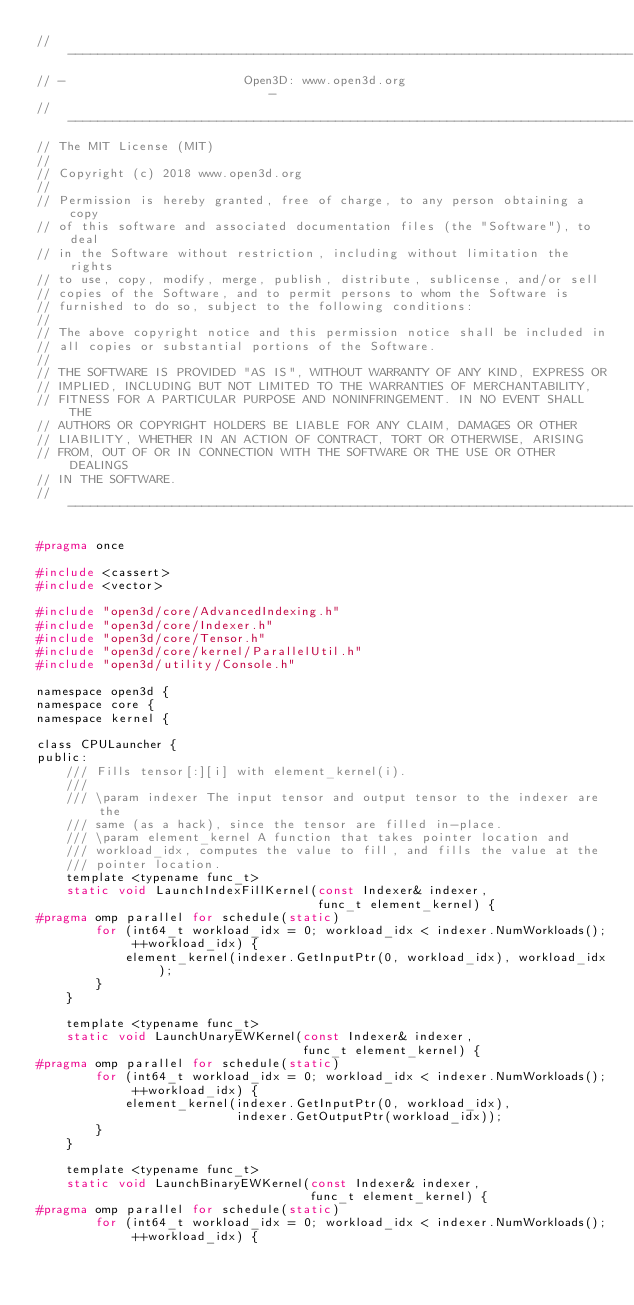<code> <loc_0><loc_0><loc_500><loc_500><_C_>// ----------------------------------------------------------------------------
// -                        Open3D: www.open3d.org                            -
// ----------------------------------------------------------------------------
// The MIT License (MIT)
//
// Copyright (c) 2018 www.open3d.org
//
// Permission is hereby granted, free of charge, to any person obtaining a copy
// of this software and associated documentation files (the "Software"), to deal
// in the Software without restriction, including without limitation the rights
// to use, copy, modify, merge, publish, distribute, sublicense, and/or sell
// copies of the Software, and to permit persons to whom the Software is
// furnished to do so, subject to the following conditions:
//
// The above copyright notice and this permission notice shall be included in
// all copies or substantial portions of the Software.
//
// THE SOFTWARE IS PROVIDED "AS IS", WITHOUT WARRANTY OF ANY KIND, EXPRESS OR
// IMPLIED, INCLUDING BUT NOT LIMITED TO THE WARRANTIES OF MERCHANTABILITY,
// FITNESS FOR A PARTICULAR PURPOSE AND NONINFRINGEMENT. IN NO EVENT SHALL THE
// AUTHORS OR COPYRIGHT HOLDERS BE LIABLE FOR ANY CLAIM, DAMAGES OR OTHER
// LIABILITY, WHETHER IN AN ACTION OF CONTRACT, TORT OR OTHERWISE, ARISING
// FROM, OUT OF OR IN CONNECTION WITH THE SOFTWARE OR THE USE OR OTHER DEALINGS
// IN THE SOFTWARE.
// ----------------------------------------------------------------------------

#pragma once

#include <cassert>
#include <vector>

#include "open3d/core/AdvancedIndexing.h"
#include "open3d/core/Indexer.h"
#include "open3d/core/Tensor.h"
#include "open3d/core/kernel/ParallelUtil.h"
#include "open3d/utility/Console.h"

namespace open3d {
namespace core {
namespace kernel {

class CPULauncher {
public:
    /// Fills tensor[:][i] with element_kernel(i).
    ///
    /// \param indexer The input tensor and output tensor to the indexer are the
    /// same (as a hack), since the tensor are filled in-place.
    /// \param element_kernel A function that takes pointer location and
    /// workload_idx, computes the value to fill, and fills the value at the
    /// pointer location.
    template <typename func_t>
    static void LaunchIndexFillKernel(const Indexer& indexer,
                                      func_t element_kernel) {
#pragma omp parallel for schedule(static)
        for (int64_t workload_idx = 0; workload_idx < indexer.NumWorkloads();
             ++workload_idx) {
            element_kernel(indexer.GetInputPtr(0, workload_idx), workload_idx);
        }
    }

    template <typename func_t>
    static void LaunchUnaryEWKernel(const Indexer& indexer,
                                    func_t element_kernel) {
#pragma omp parallel for schedule(static)
        for (int64_t workload_idx = 0; workload_idx < indexer.NumWorkloads();
             ++workload_idx) {
            element_kernel(indexer.GetInputPtr(0, workload_idx),
                           indexer.GetOutputPtr(workload_idx));
        }
    }

    template <typename func_t>
    static void LaunchBinaryEWKernel(const Indexer& indexer,
                                     func_t element_kernel) {
#pragma omp parallel for schedule(static)
        for (int64_t workload_idx = 0; workload_idx < indexer.NumWorkloads();
             ++workload_idx) {</code> 